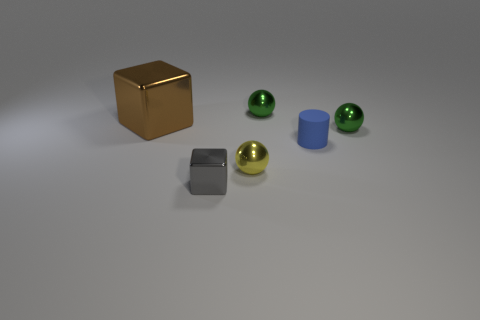Subtract all green metallic balls. How many balls are left? 1 Subtract all cyan cubes. How many green spheres are left? 2 Add 3 metal balls. How many objects exist? 9 Subtract all cylinders. How many objects are left? 5 Subtract 1 gray blocks. How many objects are left? 5 Subtract all shiny blocks. Subtract all tiny green objects. How many objects are left? 2 Add 6 small blue rubber cylinders. How many small blue rubber cylinders are left? 7 Add 1 big blue cylinders. How many big blue cylinders exist? 1 